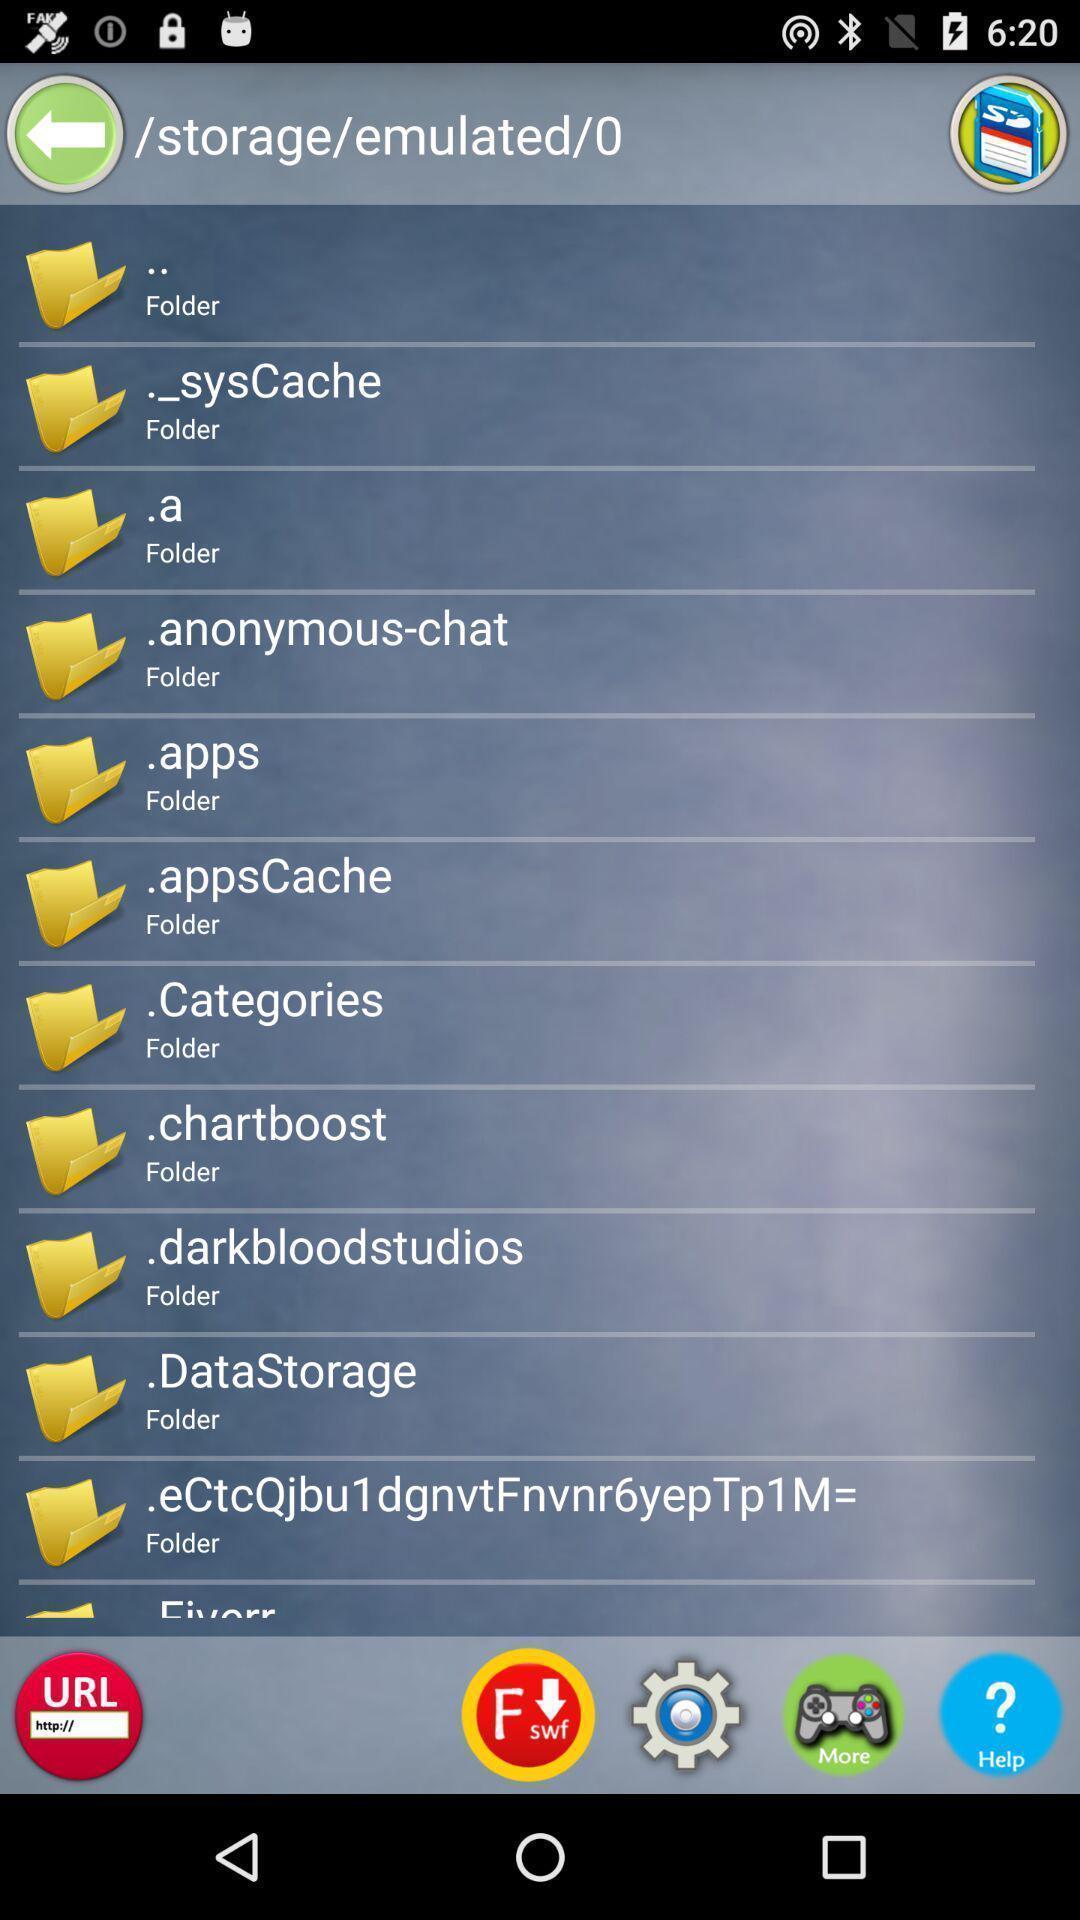What details can you identify in this image? Screen displaying the list of folders in storage page. 